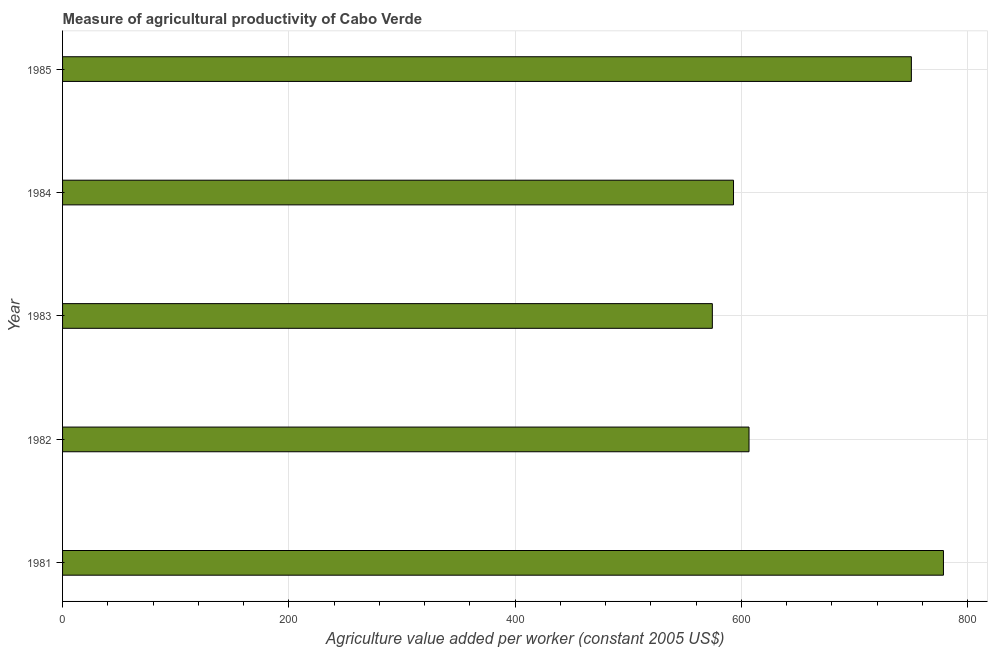Does the graph contain any zero values?
Keep it short and to the point. No. What is the title of the graph?
Offer a terse response. Measure of agricultural productivity of Cabo Verde. What is the label or title of the X-axis?
Offer a terse response. Agriculture value added per worker (constant 2005 US$). What is the agriculture value added per worker in 1985?
Give a very brief answer. 750.28. Across all years, what is the maximum agriculture value added per worker?
Your answer should be very brief. 778.63. Across all years, what is the minimum agriculture value added per worker?
Your response must be concise. 574.36. In which year was the agriculture value added per worker minimum?
Your answer should be very brief. 1983. What is the sum of the agriculture value added per worker?
Make the answer very short. 3303.1. What is the difference between the agriculture value added per worker in 1981 and 1982?
Make the answer very short. 171.86. What is the average agriculture value added per worker per year?
Give a very brief answer. 660.62. What is the median agriculture value added per worker?
Your response must be concise. 606.77. What is the ratio of the agriculture value added per worker in 1981 to that in 1983?
Offer a terse response. 1.36. What is the difference between the highest and the second highest agriculture value added per worker?
Provide a succinct answer. 28.35. Is the sum of the agriculture value added per worker in 1981 and 1983 greater than the maximum agriculture value added per worker across all years?
Provide a succinct answer. Yes. What is the difference between the highest and the lowest agriculture value added per worker?
Your response must be concise. 204.27. In how many years, is the agriculture value added per worker greater than the average agriculture value added per worker taken over all years?
Provide a short and direct response. 2. Are all the bars in the graph horizontal?
Ensure brevity in your answer.  Yes. How many years are there in the graph?
Provide a short and direct response. 5. What is the difference between two consecutive major ticks on the X-axis?
Give a very brief answer. 200. What is the Agriculture value added per worker (constant 2005 US$) of 1981?
Offer a terse response. 778.63. What is the Agriculture value added per worker (constant 2005 US$) of 1982?
Your answer should be very brief. 606.77. What is the Agriculture value added per worker (constant 2005 US$) of 1983?
Keep it short and to the point. 574.36. What is the Agriculture value added per worker (constant 2005 US$) in 1984?
Your answer should be compact. 593.06. What is the Agriculture value added per worker (constant 2005 US$) in 1985?
Give a very brief answer. 750.28. What is the difference between the Agriculture value added per worker (constant 2005 US$) in 1981 and 1982?
Offer a very short reply. 171.86. What is the difference between the Agriculture value added per worker (constant 2005 US$) in 1981 and 1983?
Keep it short and to the point. 204.27. What is the difference between the Agriculture value added per worker (constant 2005 US$) in 1981 and 1984?
Provide a short and direct response. 185.57. What is the difference between the Agriculture value added per worker (constant 2005 US$) in 1981 and 1985?
Give a very brief answer. 28.35. What is the difference between the Agriculture value added per worker (constant 2005 US$) in 1982 and 1983?
Keep it short and to the point. 32.42. What is the difference between the Agriculture value added per worker (constant 2005 US$) in 1982 and 1984?
Provide a succinct answer. 13.71. What is the difference between the Agriculture value added per worker (constant 2005 US$) in 1982 and 1985?
Your answer should be compact. -143.51. What is the difference between the Agriculture value added per worker (constant 2005 US$) in 1983 and 1984?
Give a very brief answer. -18.7. What is the difference between the Agriculture value added per worker (constant 2005 US$) in 1983 and 1985?
Your response must be concise. -175.93. What is the difference between the Agriculture value added per worker (constant 2005 US$) in 1984 and 1985?
Your answer should be compact. -157.22. What is the ratio of the Agriculture value added per worker (constant 2005 US$) in 1981 to that in 1982?
Offer a very short reply. 1.28. What is the ratio of the Agriculture value added per worker (constant 2005 US$) in 1981 to that in 1983?
Your answer should be very brief. 1.36. What is the ratio of the Agriculture value added per worker (constant 2005 US$) in 1981 to that in 1984?
Your response must be concise. 1.31. What is the ratio of the Agriculture value added per worker (constant 2005 US$) in 1981 to that in 1985?
Your answer should be very brief. 1.04. What is the ratio of the Agriculture value added per worker (constant 2005 US$) in 1982 to that in 1983?
Keep it short and to the point. 1.06. What is the ratio of the Agriculture value added per worker (constant 2005 US$) in 1982 to that in 1984?
Provide a succinct answer. 1.02. What is the ratio of the Agriculture value added per worker (constant 2005 US$) in 1982 to that in 1985?
Make the answer very short. 0.81. What is the ratio of the Agriculture value added per worker (constant 2005 US$) in 1983 to that in 1984?
Ensure brevity in your answer.  0.97. What is the ratio of the Agriculture value added per worker (constant 2005 US$) in 1983 to that in 1985?
Ensure brevity in your answer.  0.77. What is the ratio of the Agriculture value added per worker (constant 2005 US$) in 1984 to that in 1985?
Provide a short and direct response. 0.79. 